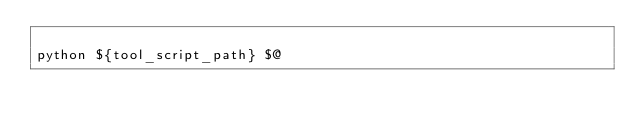Convert code to text. <code><loc_0><loc_0><loc_500><loc_500><_Bash_>
python ${tool_script_path} $@
</code> 